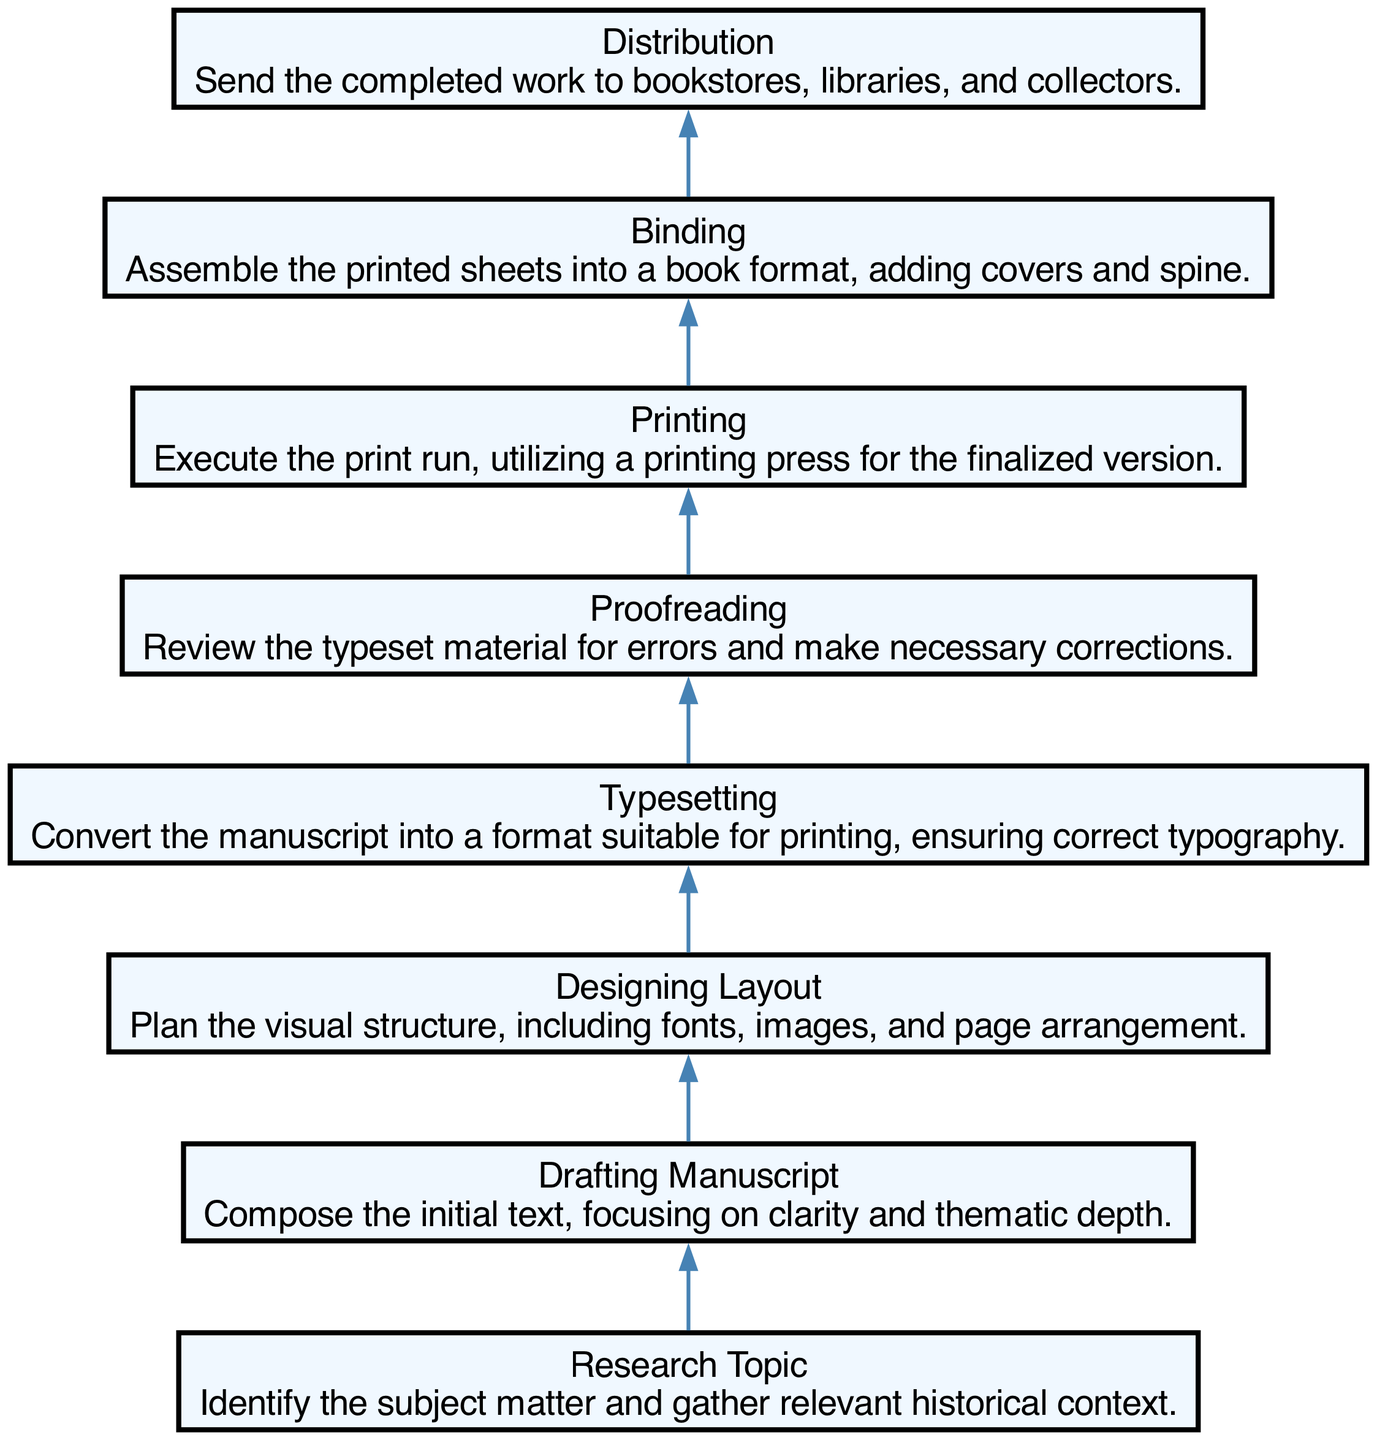What is the first step in the printing process? The diagram starts with the "Research Topic" node, which indicates that the process begins by identifying the subject matter and gathering historical context.
Answer: Research Topic How many steps are there in total from conception to distribution? By counting the nodes in the diagram, there are a total of eight steps listed, which include Research Topic, Drafting Manuscript, Designing Layout, Typesetting, Proofreading, Printing, Binding, and Distribution.
Answer: Eight What step comes after proofreading? The diagram indicates that "Printing" follows "Proofreading", demonstrating the flow from reviewing typeset material to executing the print run.
Answer: Printing Which step involves converting the manuscript into a printable format? The "Typesetting" node describes the process of converting the manuscript into a format suitable for printing, ensuring correct typography.
Answer: Typesetting What is the final step in creating a printed work? The flow concludes with the "Distribution" step, where the completed work is sent to bookstores, libraries, and collectors.
Answer: Distribution Which two steps are directly connected without any intervening steps? The "Typesetting" and "Proofreading" steps are directly connected in the diagram, showing the progression from formatting to error review.
Answer: Typesetting and Proofreading In what step is clarity and thematic depth emphasized? The "Drafting Manuscript" step emphasizes clarity and thematic depth as the initial text is composed during this phase.
Answer: Drafting Manuscript How many steps are there between Research Topic and Distribution? There are six steps between "Research Topic" and "Distribution" including Drafting Manuscript, Designing Layout, Typesetting, Proofreading, Printing, and Binding.
Answer: Six What does the binding step involve? The "Binding" step involves assembling the printed sheets into a book format, adding covers and spine. This is directly extracted from the description within the node.
Answer: Assembling printed sheets into a book format 